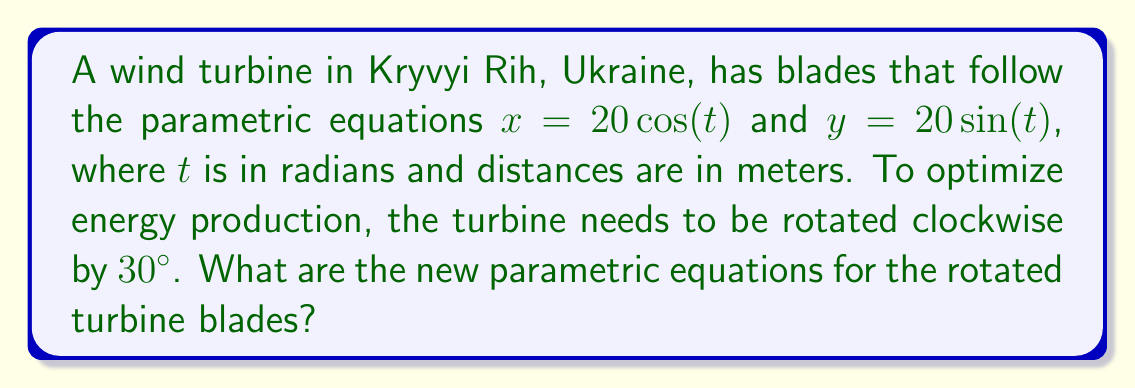Give your solution to this math problem. To solve this problem, we'll apply a rotational transformation to the given parametric equations. The steps are as follows:

1) The general rotation matrix for a clockwise rotation by angle $\theta$ is:

   $$R = \begin{bmatrix} \cos\theta & \sin\theta \\ -\sin\theta & \cos\theta \end{bmatrix}$$

2) For a 30° clockwise rotation, $\theta = 30° = \frac{\pi}{6}$ radians. Let's substitute this into our rotation matrix:

   $$R = \begin{bmatrix} \cos(\frac{\pi}{6}) & \sin(\frac{\pi}{6}) \\ -\sin(\frac{\pi}{6}) & \cos(\frac{\pi}{6}) \end{bmatrix}$$

3) We can simplify this using known values of sine and cosine:

   $$R = \begin{bmatrix} \frac{\sqrt{3}}{2} & \frac{1}{2} \\ -\frac{1}{2} & \frac{\sqrt{3}}{2} \end{bmatrix}$$

4) Now, we apply this rotation matrix to our original parametric equations:

   $$\begin{bmatrix} x' \\ y' \end{bmatrix} = \begin{bmatrix} \frac{\sqrt{3}}{2} & \frac{1}{2} \\ -\frac{1}{2} & \frac{\sqrt{3}}{2} \end{bmatrix} \begin{bmatrix} 20\cos(t) \\ 20\sin(t) \end{bmatrix}$$

5) Multiplying these matrices:

   $$\begin{align}
   x' &= \frac{\sqrt{3}}{2}(20\cos(t)) + \frac{1}{2}(20\sin(t)) \\
   y' &= -\frac{1}{2}(20\cos(t)) + \frac{\sqrt{3}}{2}(20\sin(t))
   \end{align}$$

6) Simplifying:

   $$\begin{align}
   x' &= 10\sqrt{3}\cos(t) + 10\sin(t) \\
   y' &= -10\cos(t) + 10\sqrt{3}\sin(t)
   \end{align}$$

These are the new parametric equations for the rotated turbine blades.
Answer: $x' = 10\sqrt{3}\cos(t) + 10\sin(t)$, $y' = -10\cos(t) + 10\sqrt{3}\sin(t)$ 